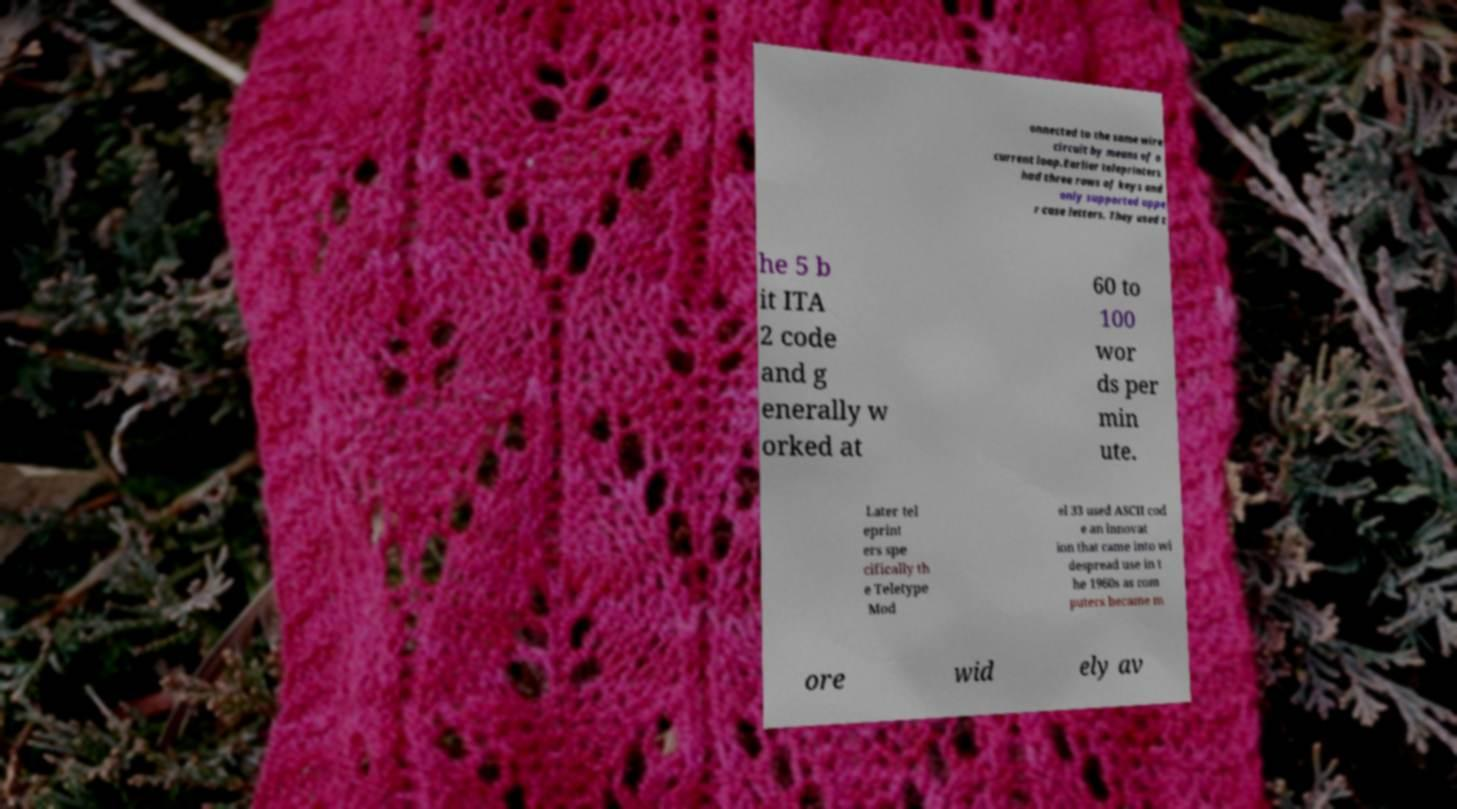Could you assist in decoding the text presented in this image and type it out clearly? onnected to the same wire circuit by means of a current loop.Earlier teleprinters had three rows of keys and only supported uppe r case letters. They used t he 5 b it ITA 2 code and g enerally w orked at 60 to 100 wor ds per min ute. Later tel eprint ers spe cifically th e Teletype Mod el 33 used ASCII cod e an innovat ion that came into wi despread use in t he 1960s as com puters became m ore wid ely av 